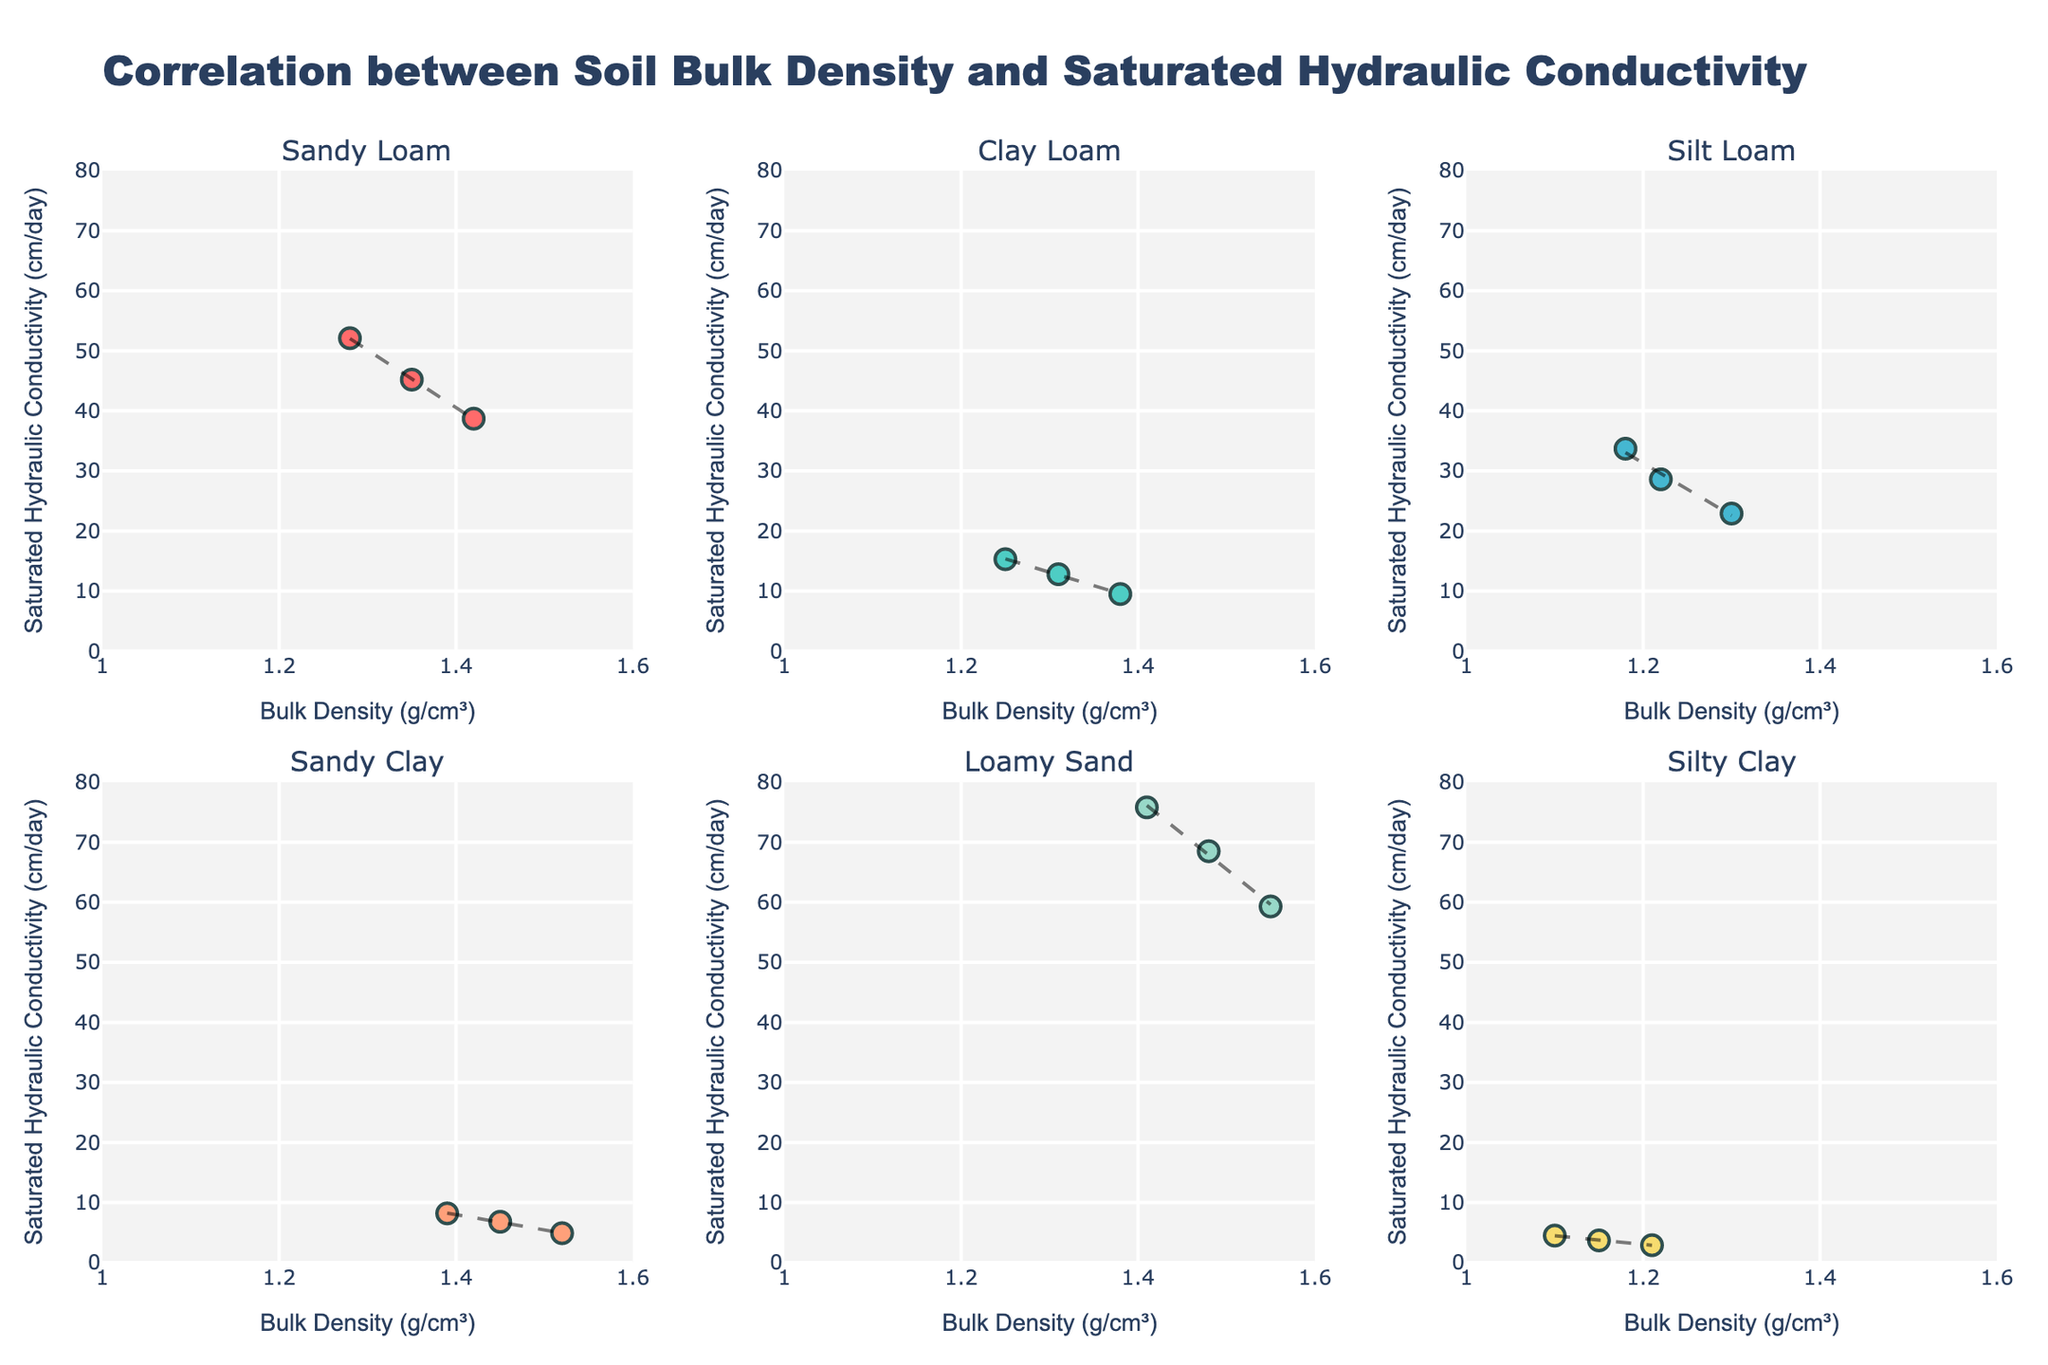What is the title of the figure? The title of the figure is usually located at the top and clearly describes the content of the plot. By looking at the top of the figure, we see "Correlation between Soil Bulk Density and Saturated Hydraulic Conductivity" is the title.
Answer: Correlation between Soil Bulk Density and Saturated Hydraulic Conductivity What is the x-axis representing in the plot? The x-axis label is typically shown along the horizontal axis in each subplot. By examining the figure, we see that the x-axis is labeled "Bulk Density (g/cm³)" in each subplot.
Answer: Bulk Density (g/cm³) How many subplots are there in the figure? By visually counting the number of smaller individual plots within the larger figure grid, we see that there are 6 subplots, each for a different soil texture (Sandy Loam, Clay Loam, Silt Loam, Sandy Clay, Loamy Sand, Silty Clay).
Answer: 6 Which soil texture has the highest measured Saturated Hydraulic Conductivity value? To answer this, check the y-axis values in each subplot and identify the highest point. By examining all subplots, it is found in the "Loamy Sand" subplot with a value around 75.8 cm/day.
Answer: Loamy Sand What range is used for the y-axis across all subplots? The range on the y-axis is uniform across all subplots. By observing the y-axes, each subplot has a range from 0 to 80 cm/day.
Answer: 0 to 80 cm/day What is the trendline showing in each subplot? Each subplot shows a scatter plot with a trendline overlaid. The trendline is added to display the general trend of the data points using a line of best fit, often indicating whether there is a positive or negative correlation between bulk density and saturated hydraulic conductivity.
Answer: The trendline shows the general trend of the data points Which soil texture appears to have a negative correlation between bulk density and saturated hydraulic conductivity? We determine the negative correlation by examining the slope of the trendline in each subplot. The subplot for "Sandy Loam" shows a trendline sloping downwards, indicating a negative correlation.
Answer: Sandy Loam Between Sandy Clay and Silty Clay, which one has generally higher values of saturated hydraulic conductivity? Check the y-values of the data points in the subplots for Sandy Clay and Silty Clay. The data points for Sandy Clay are generally higher than those for Silty Clay.
Answer: Sandy Clay How does the bulk density of Silty Clay compare to Sandy Clay? Compare the x-values of the data points in the subplots for Silty Clay and Sandy Clay. The bulk density values for Silty Clay (ranging around 1.10 to 1.21 g/cm³) are generally lower than those for Sandy Clay (ranging around 1.39 to 1.52 g/cm³).
Answer: Lower 